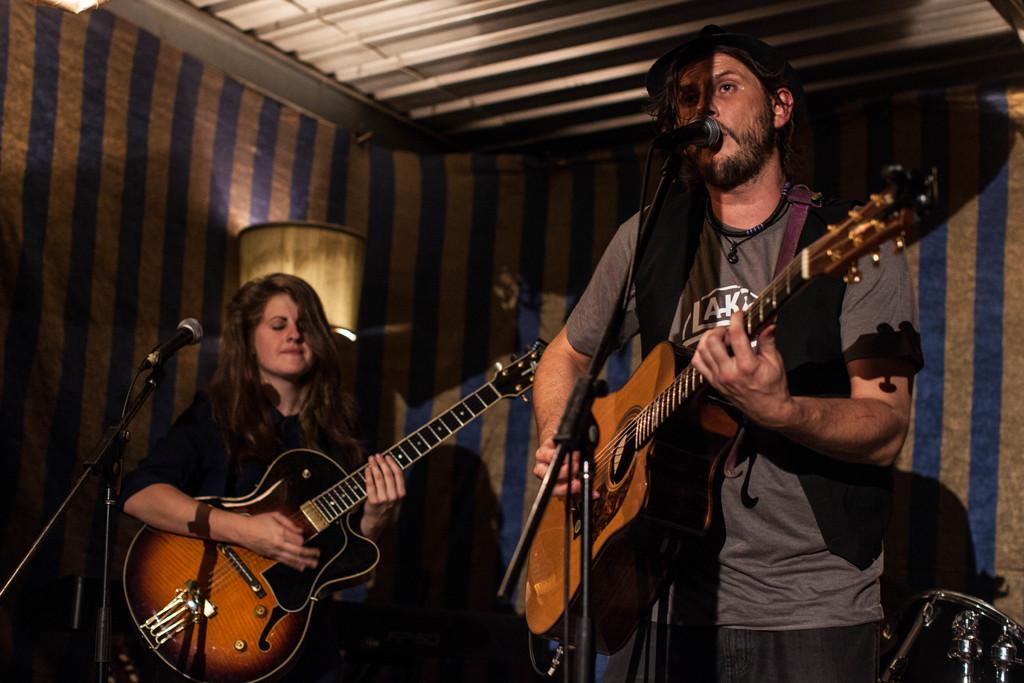Who are the people in the image? There is a woman and a man in the image. What are they doing in the image? They are standing in front of a microphone and playing a guitar. What can be seen in the background of the image? There is a wall in the background of the image. What type of pancake is the woman wearing in the image? There is no pancake or collar present in the image. 